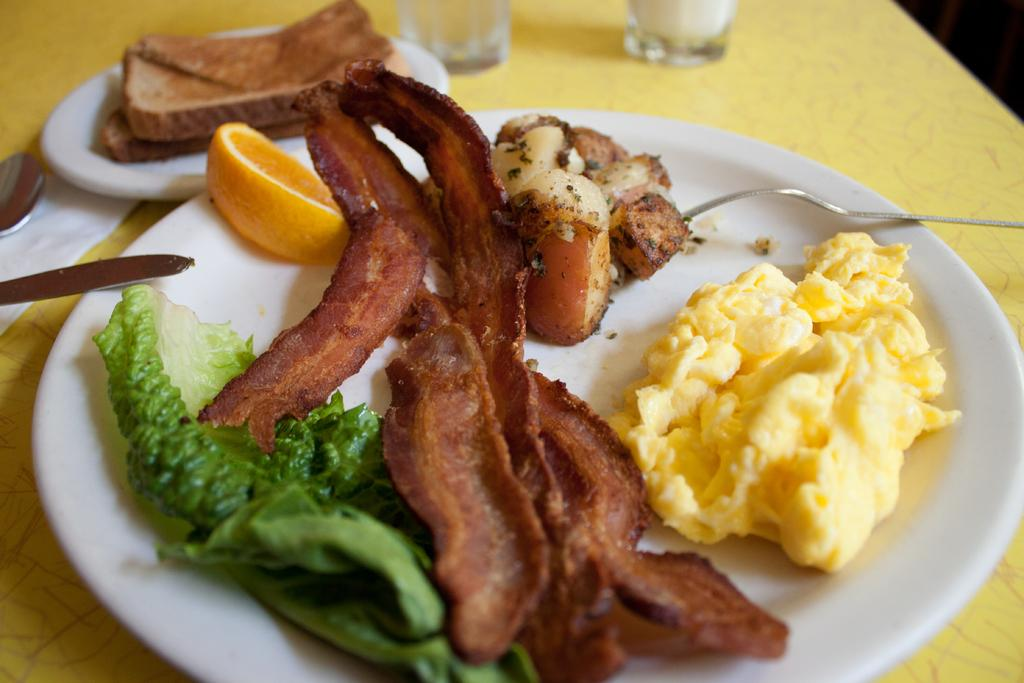What type of tableware can be seen in the image? There are plates and glasses in the image. What is on the plates? There are food items on the plates. What type of disposable item is present in the image? There is a tissue paper in the image. What utensils can be seen in the image? There is a fork, spoons, and glasses in the image. Where are all these items located? All these items are on a platform. What reason do the geese have for visiting the platform in the image? There are no geese present in the image, so there is no reason for them to visit the platform. 